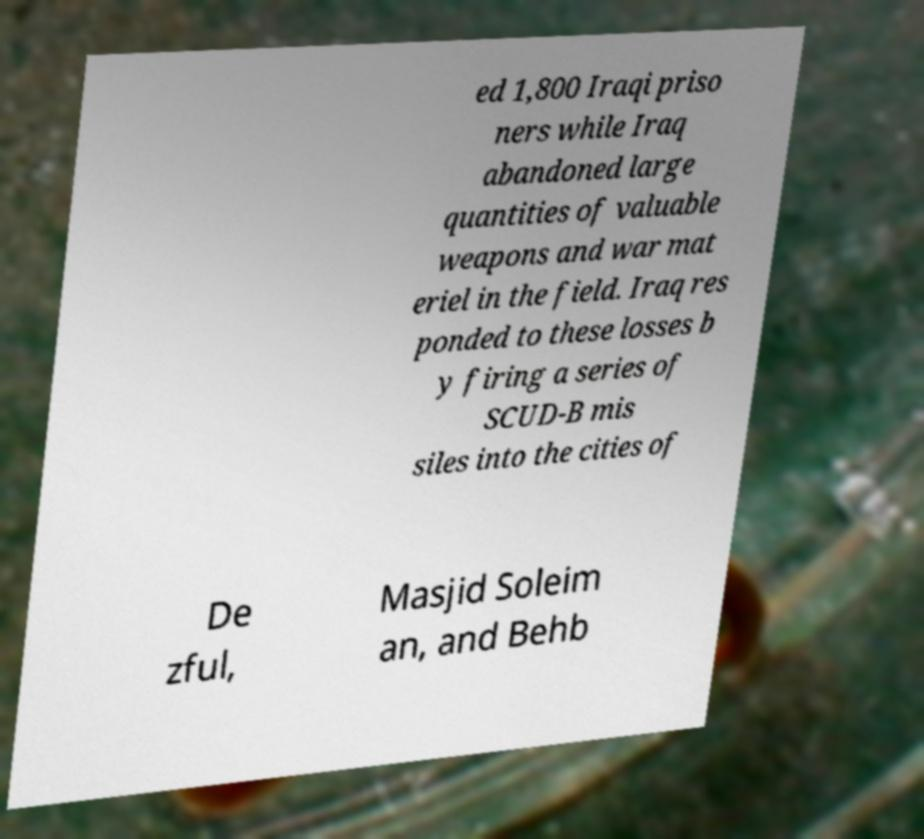Please identify and transcribe the text found in this image. ed 1,800 Iraqi priso ners while Iraq abandoned large quantities of valuable weapons and war mat eriel in the field. Iraq res ponded to these losses b y firing a series of SCUD-B mis siles into the cities of De zful, Masjid Soleim an, and Behb 